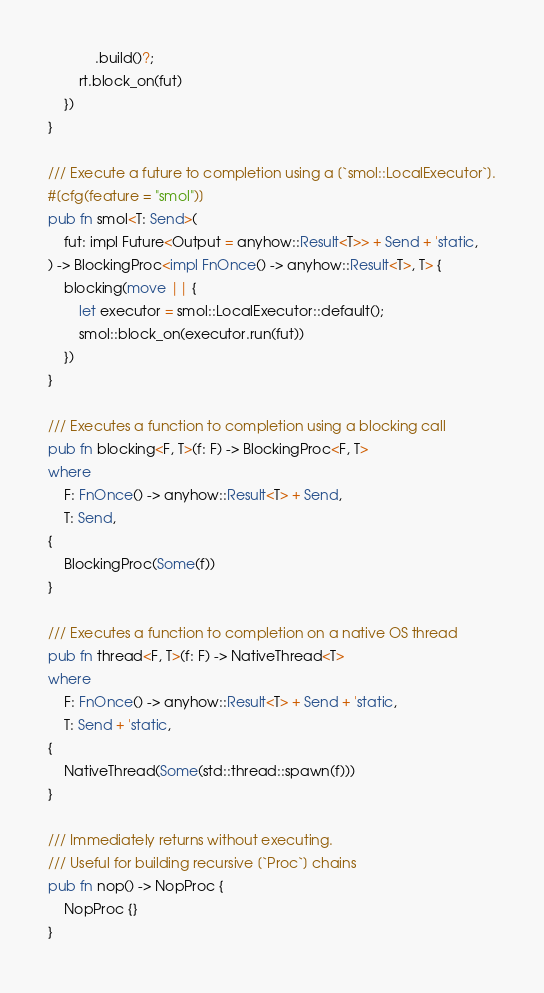Convert code to text. <code><loc_0><loc_0><loc_500><loc_500><_Rust_>            .build()?;
        rt.block_on(fut)
    })
}

/// Execute a future to completion using a [`smol::LocalExecutor`].
#[cfg(feature = "smol")]
pub fn smol<T: Send>(
    fut: impl Future<Output = anyhow::Result<T>> + Send + 'static,
) -> BlockingProc<impl FnOnce() -> anyhow::Result<T>, T> {
    blocking(move || {
        let executor = smol::LocalExecutor::default();
        smol::block_on(executor.run(fut))
    })
}

/// Executes a function to completion using a blocking call
pub fn blocking<F, T>(f: F) -> BlockingProc<F, T>
where
    F: FnOnce() -> anyhow::Result<T> + Send,
    T: Send,
{
    BlockingProc(Some(f))
}

/// Executes a function to completion on a native OS thread
pub fn thread<F, T>(f: F) -> NativeThread<T>
where
    F: FnOnce() -> anyhow::Result<T> + Send + 'static,
    T: Send + 'static,
{
    NativeThread(Some(std::thread::spawn(f)))
}

/// Immediately returns without executing.
/// Useful for building recursive [`Proc`] chains
pub fn nop() -> NopProc {
    NopProc {}
}
</code> 